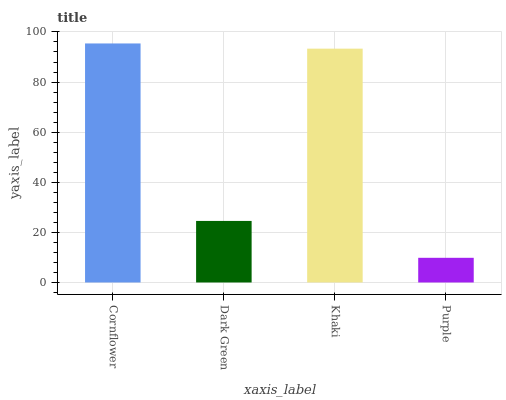Is Purple the minimum?
Answer yes or no. Yes. Is Cornflower the maximum?
Answer yes or no. Yes. Is Dark Green the minimum?
Answer yes or no. No. Is Dark Green the maximum?
Answer yes or no. No. Is Cornflower greater than Dark Green?
Answer yes or no. Yes. Is Dark Green less than Cornflower?
Answer yes or no. Yes. Is Dark Green greater than Cornflower?
Answer yes or no. No. Is Cornflower less than Dark Green?
Answer yes or no. No. Is Khaki the high median?
Answer yes or no. Yes. Is Dark Green the low median?
Answer yes or no. Yes. Is Cornflower the high median?
Answer yes or no. No. Is Cornflower the low median?
Answer yes or no. No. 